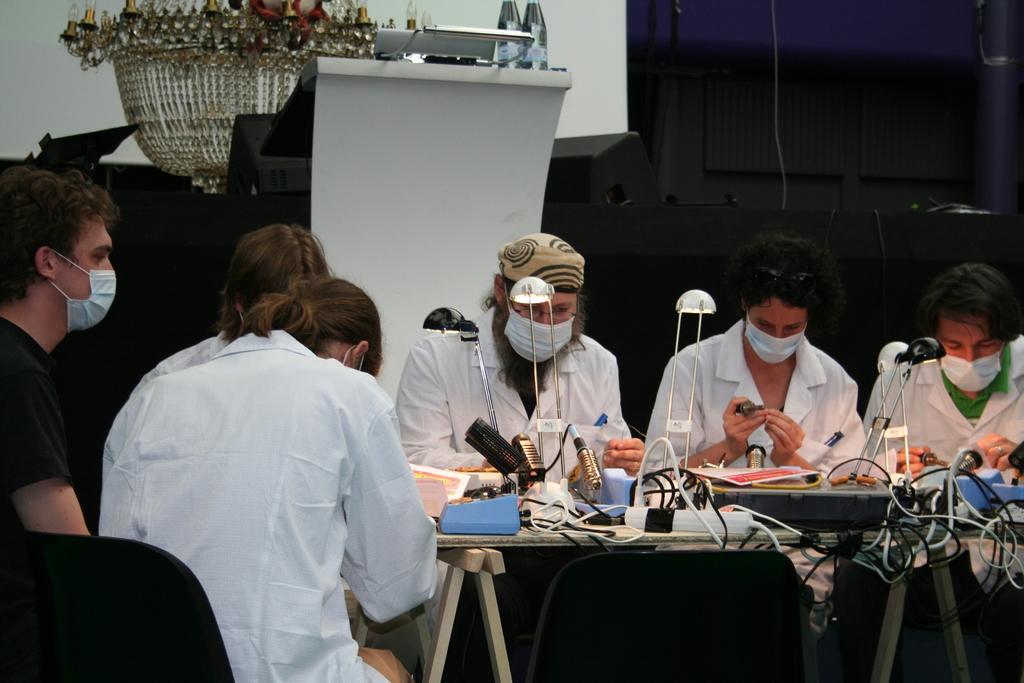How would you summarize this image in a sentence or two? In this image we can see people sitting on the chairs and a table is placed in front of them. On the table there are some machines and cables connected to them. In the background there are chairs, desktops, disposable bottles and a chandelier. 